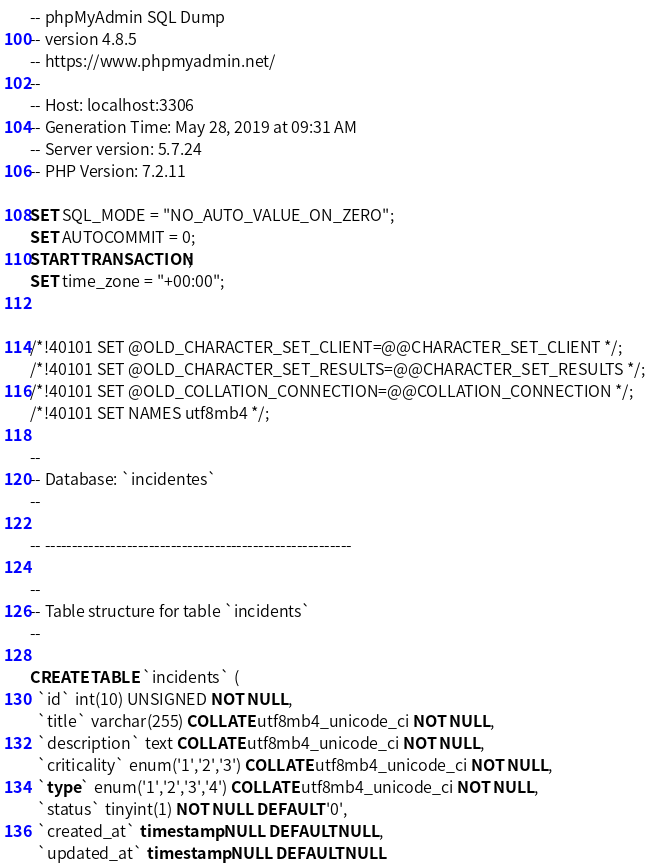<code> <loc_0><loc_0><loc_500><loc_500><_SQL_>-- phpMyAdmin SQL Dump
-- version 4.8.5
-- https://www.phpmyadmin.net/
--
-- Host: localhost:3306
-- Generation Time: May 28, 2019 at 09:31 AM
-- Server version: 5.7.24
-- PHP Version: 7.2.11

SET SQL_MODE = "NO_AUTO_VALUE_ON_ZERO";
SET AUTOCOMMIT = 0;
START TRANSACTION;
SET time_zone = "+00:00";


/*!40101 SET @OLD_CHARACTER_SET_CLIENT=@@CHARACTER_SET_CLIENT */;
/*!40101 SET @OLD_CHARACTER_SET_RESULTS=@@CHARACTER_SET_RESULTS */;
/*!40101 SET @OLD_COLLATION_CONNECTION=@@COLLATION_CONNECTION */;
/*!40101 SET NAMES utf8mb4 */;

--
-- Database: `incidentes`
--

-- --------------------------------------------------------

--
-- Table structure for table `incidents`
--

CREATE TABLE `incidents` (
  `id` int(10) UNSIGNED NOT NULL,
  `title` varchar(255) COLLATE utf8mb4_unicode_ci NOT NULL,
  `description` text COLLATE utf8mb4_unicode_ci NOT NULL,
  `criticality` enum('1','2','3') COLLATE utf8mb4_unicode_ci NOT NULL,
  `type` enum('1','2','3','4') COLLATE utf8mb4_unicode_ci NOT NULL,
  `status` tinyint(1) NOT NULL DEFAULT '0',
  `created_at` timestamp NULL DEFAULT NULL,
  `updated_at` timestamp NULL DEFAULT NULL</code> 